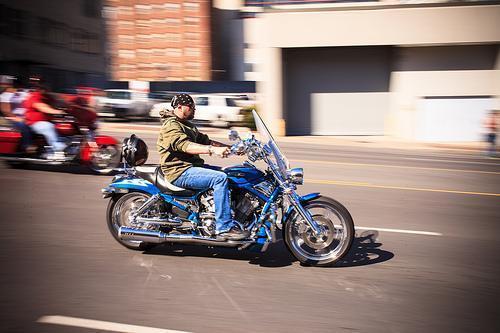How many bikes are in the picture?
Give a very brief answer. 2. 